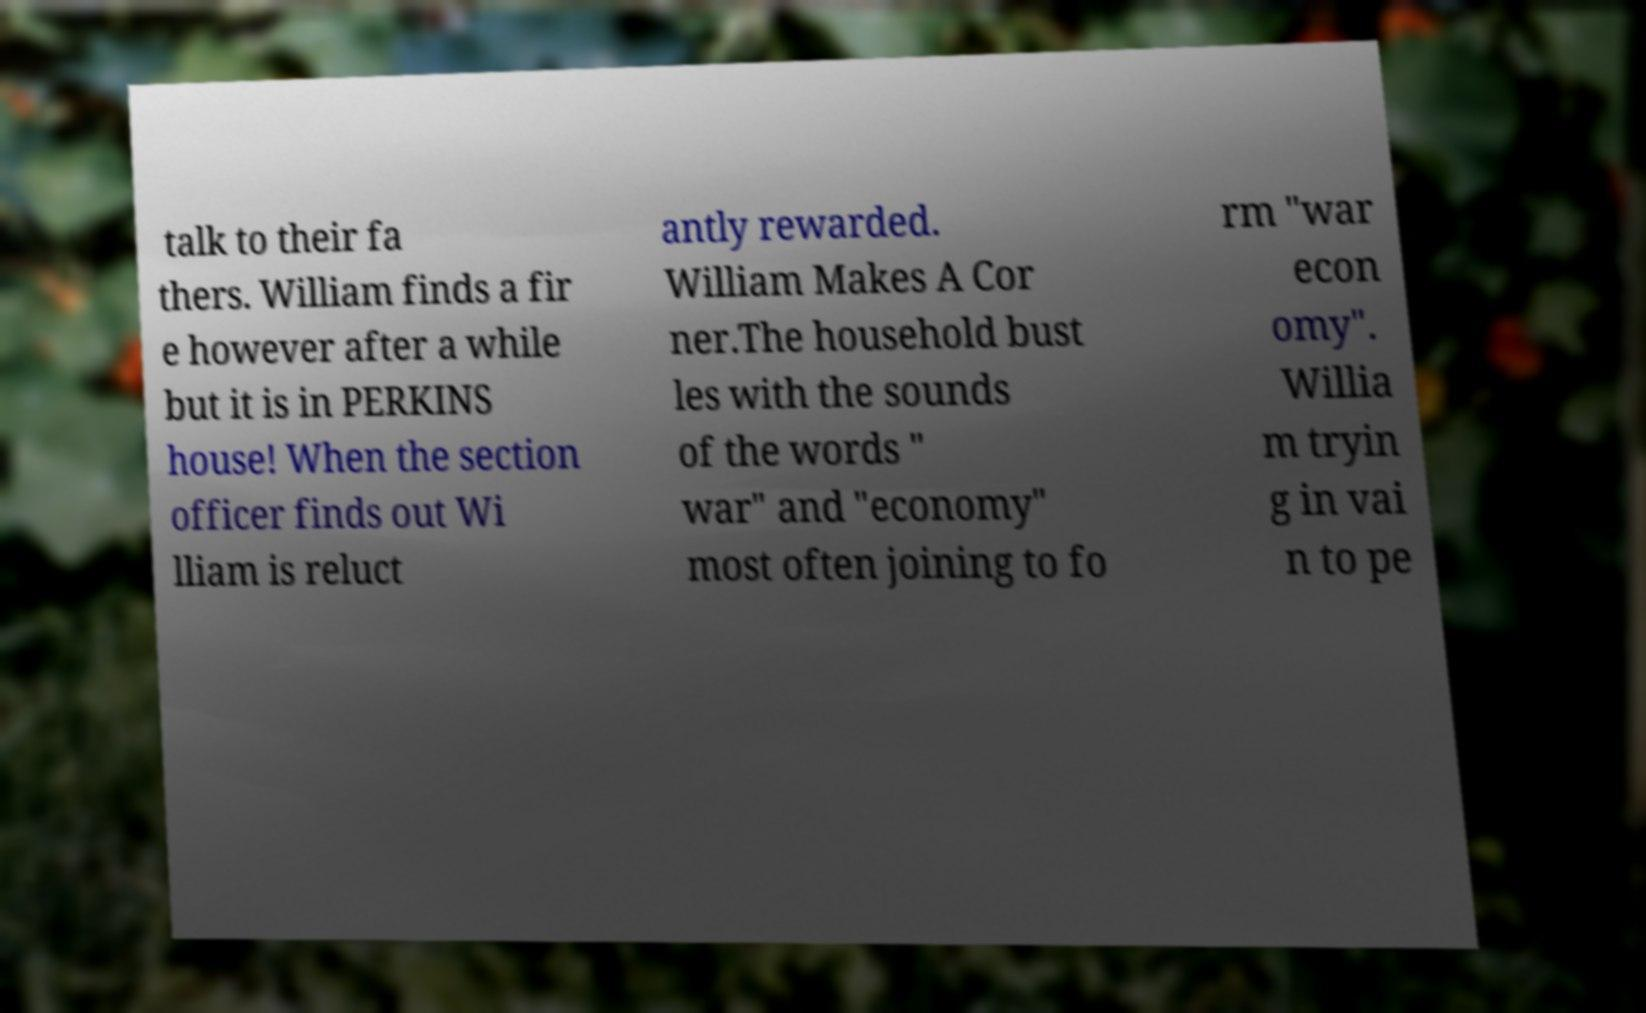Please read and relay the text visible in this image. What does it say? talk to their fa thers. William finds a fir e however after a while but it is in PERKINS house! When the section officer finds out Wi lliam is reluct antly rewarded. William Makes A Cor ner.The household bust les with the sounds of the words " war" and "economy" most often joining to fo rm "war econ omy". Willia m tryin g in vai n to pe 